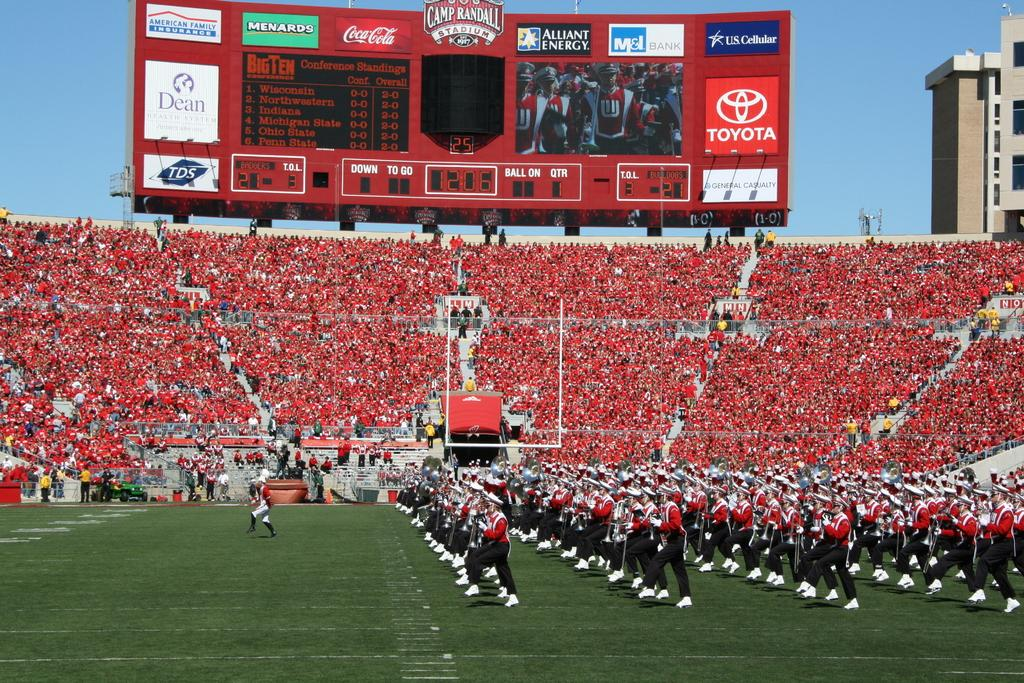<image>
Relay a brief, clear account of the picture shown. An open football field with a large score board titled Camp Randall Stadium. 